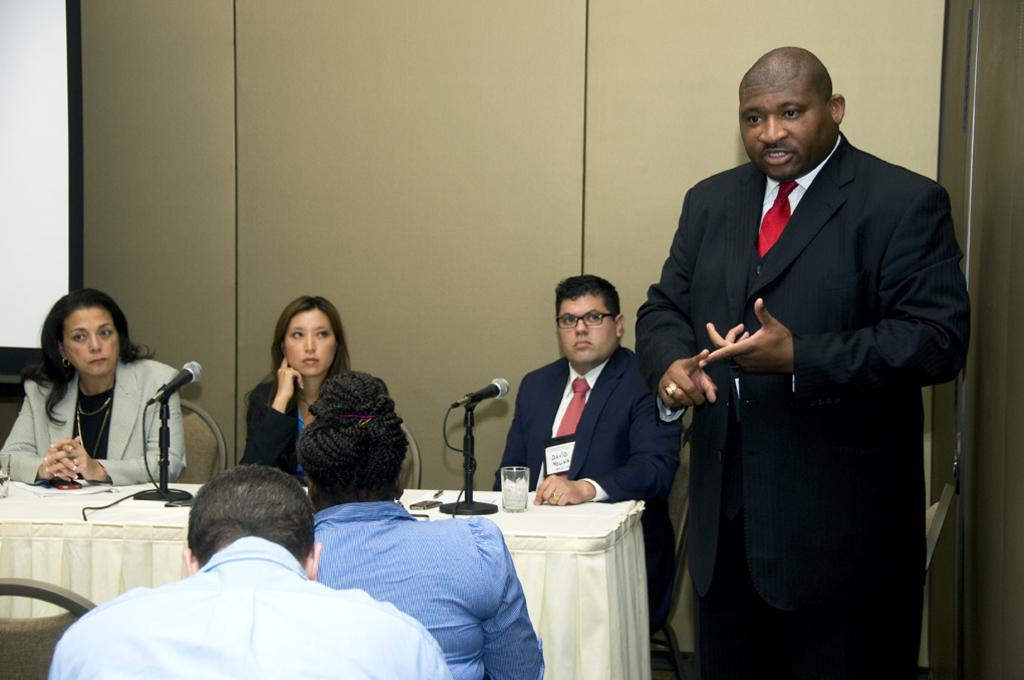Describe this image in one or two sentences. In this image I can see on the right side a man is talking, he wore black color coat. On the left side 2 women are sitting on the chairs and listening to him. There are microphones and water glasses on this table, at the bottom two men are there. 